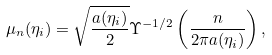<formula> <loc_0><loc_0><loc_500><loc_500>\mu _ { n } ( \eta _ { i } ) = \sqrt { \frac { a ( \eta _ { i } ) } 2 } \Upsilon ^ { - 1 / 2 } \left ( \frac { n } { 2 \pi a ( \eta _ { i } ) } \right ) ,</formula> 